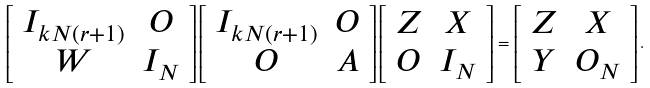Convert formula to latex. <formula><loc_0><loc_0><loc_500><loc_500>\left [ \begin{array} { c c } I _ { k N ( r + 1 ) } & O \\ W & I _ { N } \end{array} \right ] \left [ \begin{array} { c c } I _ { k N ( r + 1 ) } & O \\ O & A \end{array} \right ] \left [ \begin{array} { c c } Z & X \\ O & I _ { N } \end{array} \right ] = \left [ \begin{array} { c c } Z & X \\ Y & O _ { N } \end{array} \right ] .</formula> 